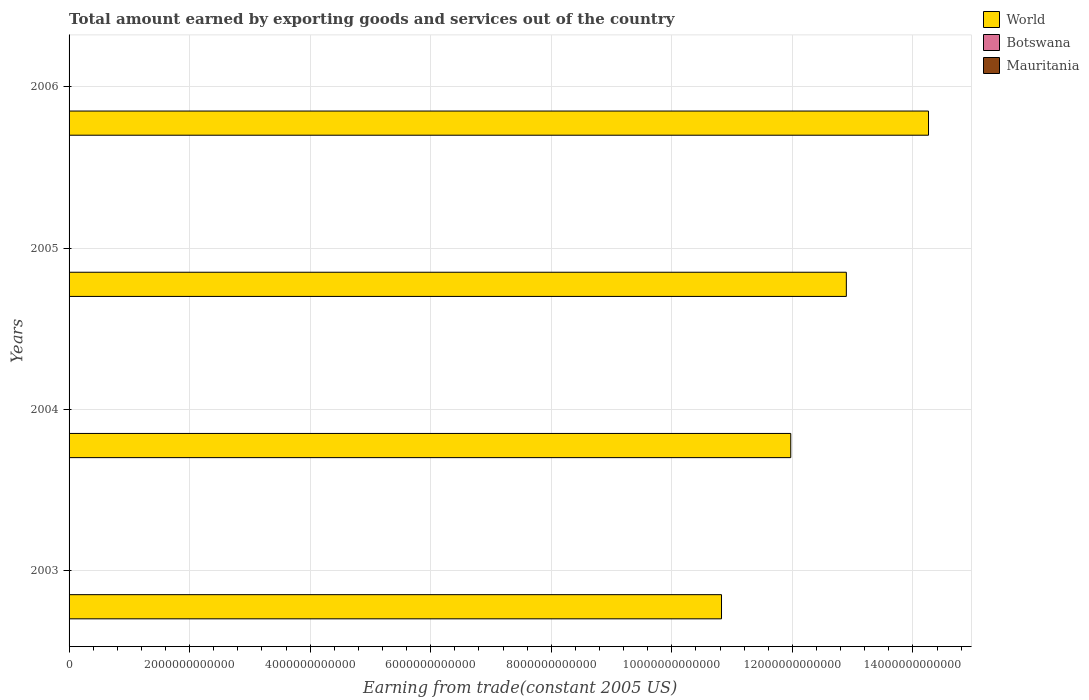How many different coloured bars are there?
Your answer should be compact. 3. Are the number of bars on each tick of the Y-axis equal?
Offer a terse response. Yes. What is the label of the 4th group of bars from the top?
Provide a succinct answer. 2003. In how many cases, is the number of bars for a given year not equal to the number of legend labels?
Ensure brevity in your answer.  0. What is the total amount earned by exporting goods and services in World in 2003?
Your response must be concise. 1.08e+13. Across all years, what is the maximum total amount earned by exporting goods and services in Botswana?
Make the answer very short. 5.42e+09. Across all years, what is the minimum total amount earned by exporting goods and services in World?
Make the answer very short. 1.08e+13. In which year was the total amount earned by exporting goods and services in Botswana minimum?
Ensure brevity in your answer.  2003. What is the total total amount earned by exporting goods and services in Botswana in the graph?
Provide a succinct answer. 1.93e+1. What is the difference between the total amount earned by exporting goods and services in World in 2003 and that in 2006?
Make the answer very short. -3.43e+12. What is the difference between the total amount earned by exporting goods and services in World in 2006 and the total amount earned by exporting goods and services in Mauritania in 2003?
Ensure brevity in your answer.  1.43e+13. What is the average total amount earned by exporting goods and services in Botswana per year?
Offer a very short reply. 4.82e+09. In the year 2003, what is the difference between the total amount earned by exporting goods and services in Botswana and total amount earned by exporting goods and services in Mauritania?
Your answer should be very brief. 3.61e+09. In how many years, is the total amount earned by exporting goods and services in Mauritania greater than 6400000000000 US$?
Make the answer very short. 0. What is the ratio of the total amount earned by exporting goods and services in Botswana in 2003 to that in 2004?
Give a very brief answer. 0.93. What is the difference between the highest and the second highest total amount earned by exporting goods and services in World?
Ensure brevity in your answer.  1.36e+12. What is the difference between the highest and the lowest total amount earned by exporting goods and services in Botswana?
Give a very brief answer. 1.28e+09. What does the 1st bar from the top in 2003 represents?
Offer a very short reply. Mauritania. Is it the case that in every year, the sum of the total amount earned by exporting goods and services in World and total amount earned by exporting goods and services in Mauritania is greater than the total amount earned by exporting goods and services in Botswana?
Make the answer very short. Yes. How many years are there in the graph?
Provide a short and direct response. 4. What is the difference between two consecutive major ticks on the X-axis?
Your answer should be very brief. 2.00e+12. Are the values on the major ticks of X-axis written in scientific E-notation?
Your answer should be compact. No. Does the graph contain any zero values?
Ensure brevity in your answer.  No. How are the legend labels stacked?
Offer a terse response. Vertical. What is the title of the graph?
Provide a short and direct response. Total amount earned by exporting goods and services out of the country. What is the label or title of the X-axis?
Your answer should be very brief. Earning from trade(constant 2005 US). What is the Earning from trade(constant 2005 US) of World in 2003?
Your answer should be very brief. 1.08e+13. What is the Earning from trade(constant 2005 US) in Botswana in 2003?
Your answer should be very brief. 4.14e+09. What is the Earning from trade(constant 2005 US) of Mauritania in 2003?
Give a very brief answer. 5.33e+08. What is the Earning from trade(constant 2005 US) in World in 2004?
Provide a succinct answer. 1.20e+13. What is the Earning from trade(constant 2005 US) in Botswana in 2004?
Your answer should be compact. 4.45e+09. What is the Earning from trade(constant 2005 US) of Mauritania in 2004?
Keep it short and to the point. 6.71e+08. What is the Earning from trade(constant 2005 US) in World in 2005?
Ensure brevity in your answer.  1.29e+13. What is the Earning from trade(constant 2005 US) in Botswana in 2005?
Provide a succinct answer. 5.26e+09. What is the Earning from trade(constant 2005 US) of Mauritania in 2005?
Give a very brief answer. 6.71e+08. What is the Earning from trade(constant 2005 US) in World in 2006?
Your response must be concise. 1.43e+13. What is the Earning from trade(constant 2005 US) of Botswana in 2006?
Keep it short and to the point. 5.42e+09. What is the Earning from trade(constant 2005 US) of Mauritania in 2006?
Your answer should be very brief. 1.10e+09. Across all years, what is the maximum Earning from trade(constant 2005 US) in World?
Offer a terse response. 1.43e+13. Across all years, what is the maximum Earning from trade(constant 2005 US) in Botswana?
Provide a succinct answer. 5.42e+09. Across all years, what is the maximum Earning from trade(constant 2005 US) of Mauritania?
Give a very brief answer. 1.10e+09. Across all years, what is the minimum Earning from trade(constant 2005 US) of World?
Ensure brevity in your answer.  1.08e+13. Across all years, what is the minimum Earning from trade(constant 2005 US) in Botswana?
Offer a terse response. 4.14e+09. Across all years, what is the minimum Earning from trade(constant 2005 US) of Mauritania?
Make the answer very short. 5.33e+08. What is the total Earning from trade(constant 2005 US) of World in the graph?
Provide a succinct answer. 5.00e+13. What is the total Earning from trade(constant 2005 US) of Botswana in the graph?
Provide a succinct answer. 1.93e+1. What is the total Earning from trade(constant 2005 US) of Mauritania in the graph?
Your answer should be very brief. 2.97e+09. What is the difference between the Earning from trade(constant 2005 US) of World in 2003 and that in 2004?
Give a very brief answer. -1.15e+12. What is the difference between the Earning from trade(constant 2005 US) of Botswana in 2003 and that in 2004?
Your answer should be very brief. -3.06e+08. What is the difference between the Earning from trade(constant 2005 US) of Mauritania in 2003 and that in 2004?
Make the answer very short. -1.38e+08. What is the difference between the Earning from trade(constant 2005 US) of World in 2003 and that in 2005?
Your answer should be very brief. -2.07e+12. What is the difference between the Earning from trade(constant 2005 US) of Botswana in 2003 and that in 2005?
Your answer should be compact. -1.11e+09. What is the difference between the Earning from trade(constant 2005 US) of Mauritania in 2003 and that in 2005?
Provide a short and direct response. -1.38e+08. What is the difference between the Earning from trade(constant 2005 US) in World in 2003 and that in 2006?
Offer a very short reply. -3.43e+12. What is the difference between the Earning from trade(constant 2005 US) of Botswana in 2003 and that in 2006?
Give a very brief answer. -1.28e+09. What is the difference between the Earning from trade(constant 2005 US) in Mauritania in 2003 and that in 2006?
Make the answer very short. -5.65e+08. What is the difference between the Earning from trade(constant 2005 US) of World in 2004 and that in 2005?
Give a very brief answer. -9.22e+11. What is the difference between the Earning from trade(constant 2005 US) in Botswana in 2004 and that in 2005?
Your answer should be very brief. -8.09e+08. What is the difference between the Earning from trade(constant 2005 US) in Mauritania in 2004 and that in 2005?
Offer a terse response. -2.69e+04. What is the difference between the Earning from trade(constant 2005 US) of World in 2004 and that in 2006?
Offer a terse response. -2.29e+12. What is the difference between the Earning from trade(constant 2005 US) of Botswana in 2004 and that in 2006?
Provide a short and direct response. -9.74e+08. What is the difference between the Earning from trade(constant 2005 US) in Mauritania in 2004 and that in 2006?
Keep it short and to the point. -4.26e+08. What is the difference between the Earning from trade(constant 2005 US) in World in 2005 and that in 2006?
Give a very brief answer. -1.36e+12. What is the difference between the Earning from trade(constant 2005 US) of Botswana in 2005 and that in 2006?
Offer a very short reply. -1.65e+08. What is the difference between the Earning from trade(constant 2005 US) of Mauritania in 2005 and that in 2006?
Your response must be concise. -4.26e+08. What is the difference between the Earning from trade(constant 2005 US) in World in 2003 and the Earning from trade(constant 2005 US) in Botswana in 2004?
Your answer should be very brief. 1.08e+13. What is the difference between the Earning from trade(constant 2005 US) of World in 2003 and the Earning from trade(constant 2005 US) of Mauritania in 2004?
Your answer should be very brief. 1.08e+13. What is the difference between the Earning from trade(constant 2005 US) of Botswana in 2003 and the Earning from trade(constant 2005 US) of Mauritania in 2004?
Provide a succinct answer. 3.47e+09. What is the difference between the Earning from trade(constant 2005 US) of World in 2003 and the Earning from trade(constant 2005 US) of Botswana in 2005?
Your answer should be compact. 1.08e+13. What is the difference between the Earning from trade(constant 2005 US) in World in 2003 and the Earning from trade(constant 2005 US) in Mauritania in 2005?
Provide a short and direct response. 1.08e+13. What is the difference between the Earning from trade(constant 2005 US) of Botswana in 2003 and the Earning from trade(constant 2005 US) of Mauritania in 2005?
Your answer should be compact. 3.47e+09. What is the difference between the Earning from trade(constant 2005 US) of World in 2003 and the Earning from trade(constant 2005 US) of Botswana in 2006?
Offer a terse response. 1.08e+13. What is the difference between the Earning from trade(constant 2005 US) of World in 2003 and the Earning from trade(constant 2005 US) of Mauritania in 2006?
Your response must be concise. 1.08e+13. What is the difference between the Earning from trade(constant 2005 US) in Botswana in 2003 and the Earning from trade(constant 2005 US) in Mauritania in 2006?
Your answer should be compact. 3.04e+09. What is the difference between the Earning from trade(constant 2005 US) in World in 2004 and the Earning from trade(constant 2005 US) in Botswana in 2005?
Make the answer very short. 1.20e+13. What is the difference between the Earning from trade(constant 2005 US) in World in 2004 and the Earning from trade(constant 2005 US) in Mauritania in 2005?
Your response must be concise. 1.20e+13. What is the difference between the Earning from trade(constant 2005 US) in Botswana in 2004 and the Earning from trade(constant 2005 US) in Mauritania in 2005?
Offer a terse response. 3.78e+09. What is the difference between the Earning from trade(constant 2005 US) of World in 2004 and the Earning from trade(constant 2005 US) of Botswana in 2006?
Give a very brief answer. 1.20e+13. What is the difference between the Earning from trade(constant 2005 US) of World in 2004 and the Earning from trade(constant 2005 US) of Mauritania in 2006?
Provide a short and direct response. 1.20e+13. What is the difference between the Earning from trade(constant 2005 US) in Botswana in 2004 and the Earning from trade(constant 2005 US) in Mauritania in 2006?
Your response must be concise. 3.35e+09. What is the difference between the Earning from trade(constant 2005 US) of World in 2005 and the Earning from trade(constant 2005 US) of Botswana in 2006?
Offer a terse response. 1.29e+13. What is the difference between the Earning from trade(constant 2005 US) of World in 2005 and the Earning from trade(constant 2005 US) of Mauritania in 2006?
Your response must be concise. 1.29e+13. What is the difference between the Earning from trade(constant 2005 US) of Botswana in 2005 and the Earning from trade(constant 2005 US) of Mauritania in 2006?
Provide a short and direct response. 4.16e+09. What is the average Earning from trade(constant 2005 US) in World per year?
Ensure brevity in your answer.  1.25e+13. What is the average Earning from trade(constant 2005 US) of Botswana per year?
Your response must be concise. 4.82e+09. What is the average Earning from trade(constant 2005 US) of Mauritania per year?
Your response must be concise. 7.43e+08. In the year 2003, what is the difference between the Earning from trade(constant 2005 US) of World and Earning from trade(constant 2005 US) of Botswana?
Make the answer very short. 1.08e+13. In the year 2003, what is the difference between the Earning from trade(constant 2005 US) of World and Earning from trade(constant 2005 US) of Mauritania?
Ensure brevity in your answer.  1.08e+13. In the year 2003, what is the difference between the Earning from trade(constant 2005 US) of Botswana and Earning from trade(constant 2005 US) of Mauritania?
Keep it short and to the point. 3.61e+09. In the year 2004, what is the difference between the Earning from trade(constant 2005 US) in World and Earning from trade(constant 2005 US) in Botswana?
Your answer should be compact. 1.20e+13. In the year 2004, what is the difference between the Earning from trade(constant 2005 US) in World and Earning from trade(constant 2005 US) in Mauritania?
Your response must be concise. 1.20e+13. In the year 2004, what is the difference between the Earning from trade(constant 2005 US) of Botswana and Earning from trade(constant 2005 US) of Mauritania?
Offer a terse response. 3.78e+09. In the year 2005, what is the difference between the Earning from trade(constant 2005 US) in World and Earning from trade(constant 2005 US) in Botswana?
Offer a terse response. 1.29e+13. In the year 2005, what is the difference between the Earning from trade(constant 2005 US) of World and Earning from trade(constant 2005 US) of Mauritania?
Your response must be concise. 1.29e+13. In the year 2005, what is the difference between the Earning from trade(constant 2005 US) in Botswana and Earning from trade(constant 2005 US) in Mauritania?
Offer a terse response. 4.58e+09. In the year 2006, what is the difference between the Earning from trade(constant 2005 US) of World and Earning from trade(constant 2005 US) of Botswana?
Your response must be concise. 1.43e+13. In the year 2006, what is the difference between the Earning from trade(constant 2005 US) in World and Earning from trade(constant 2005 US) in Mauritania?
Make the answer very short. 1.43e+13. In the year 2006, what is the difference between the Earning from trade(constant 2005 US) of Botswana and Earning from trade(constant 2005 US) of Mauritania?
Make the answer very short. 4.32e+09. What is the ratio of the Earning from trade(constant 2005 US) in World in 2003 to that in 2004?
Your response must be concise. 0.9. What is the ratio of the Earning from trade(constant 2005 US) in Botswana in 2003 to that in 2004?
Your answer should be very brief. 0.93. What is the ratio of the Earning from trade(constant 2005 US) of Mauritania in 2003 to that in 2004?
Offer a terse response. 0.79. What is the ratio of the Earning from trade(constant 2005 US) of World in 2003 to that in 2005?
Your response must be concise. 0.84. What is the ratio of the Earning from trade(constant 2005 US) in Botswana in 2003 to that in 2005?
Your response must be concise. 0.79. What is the ratio of the Earning from trade(constant 2005 US) in Mauritania in 2003 to that in 2005?
Ensure brevity in your answer.  0.79. What is the ratio of the Earning from trade(constant 2005 US) in World in 2003 to that in 2006?
Ensure brevity in your answer.  0.76. What is the ratio of the Earning from trade(constant 2005 US) in Botswana in 2003 to that in 2006?
Offer a terse response. 0.76. What is the ratio of the Earning from trade(constant 2005 US) of Mauritania in 2003 to that in 2006?
Make the answer very short. 0.49. What is the ratio of the Earning from trade(constant 2005 US) of World in 2004 to that in 2005?
Ensure brevity in your answer.  0.93. What is the ratio of the Earning from trade(constant 2005 US) in Botswana in 2004 to that in 2005?
Offer a terse response. 0.85. What is the ratio of the Earning from trade(constant 2005 US) of World in 2004 to that in 2006?
Make the answer very short. 0.84. What is the ratio of the Earning from trade(constant 2005 US) in Botswana in 2004 to that in 2006?
Give a very brief answer. 0.82. What is the ratio of the Earning from trade(constant 2005 US) in Mauritania in 2004 to that in 2006?
Offer a very short reply. 0.61. What is the ratio of the Earning from trade(constant 2005 US) of World in 2005 to that in 2006?
Your response must be concise. 0.9. What is the ratio of the Earning from trade(constant 2005 US) of Botswana in 2005 to that in 2006?
Give a very brief answer. 0.97. What is the ratio of the Earning from trade(constant 2005 US) in Mauritania in 2005 to that in 2006?
Your response must be concise. 0.61. What is the difference between the highest and the second highest Earning from trade(constant 2005 US) of World?
Your response must be concise. 1.36e+12. What is the difference between the highest and the second highest Earning from trade(constant 2005 US) in Botswana?
Provide a short and direct response. 1.65e+08. What is the difference between the highest and the second highest Earning from trade(constant 2005 US) of Mauritania?
Your response must be concise. 4.26e+08. What is the difference between the highest and the lowest Earning from trade(constant 2005 US) in World?
Offer a very short reply. 3.43e+12. What is the difference between the highest and the lowest Earning from trade(constant 2005 US) of Botswana?
Give a very brief answer. 1.28e+09. What is the difference between the highest and the lowest Earning from trade(constant 2005 US) of Mauritania?
Ensure brevity in your answer.  5.65e+08. 